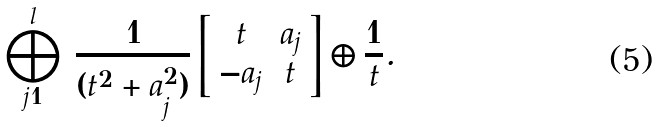Convert formula to latex. <formula><loc_0><loc_0><loc_500><loc_500>\bigoplus _ { j = 1 } ^ { l } \, \frac { 1 } { ( t ^ { 2 } + a _ { j } ^ { 2 } ) } \left [ \begin{array} { c c } t & a _ { j } \\ - a _ { j } & t \end{array} \right ] \oplus \frac { 1 } { t } .</formula> 